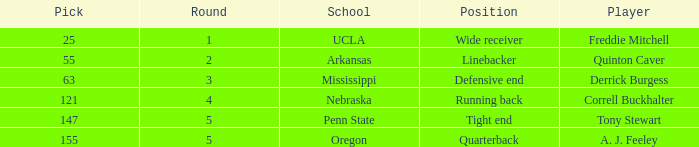What position did the player who was picked in round 3 play? Defensive end. 